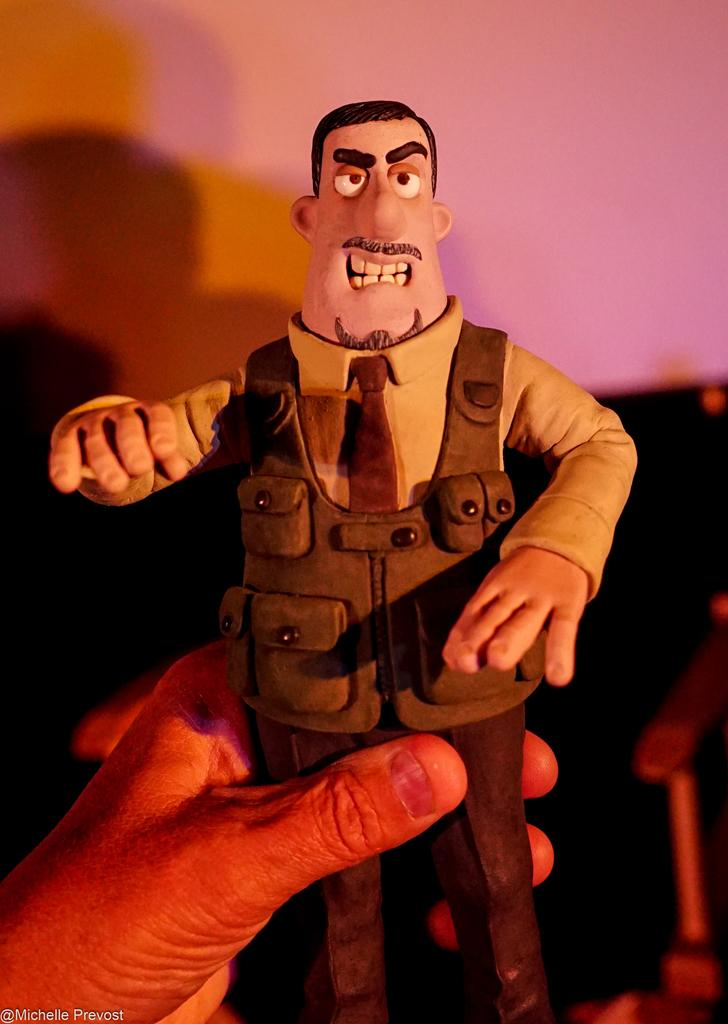What is the person holding in their hand in the image? There is a small toy in the person's hand in the image. What can be seen in the background of the image? There is a pink color wall in the background. What type of theory is the person discussing while holding the small toy in the image? There is no indication in the image that the person is discussing a theory, so it cannot be determined from the picture. 